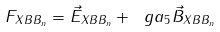<formula> <loc_0><loc_0><loc_500><loc_500>F _ { X B B _ { n } } = \vec { E } _ { X B B _ { n } } + \ g a _ { 5 } \vec { B } _ { X B B _ { n } }</formula> 